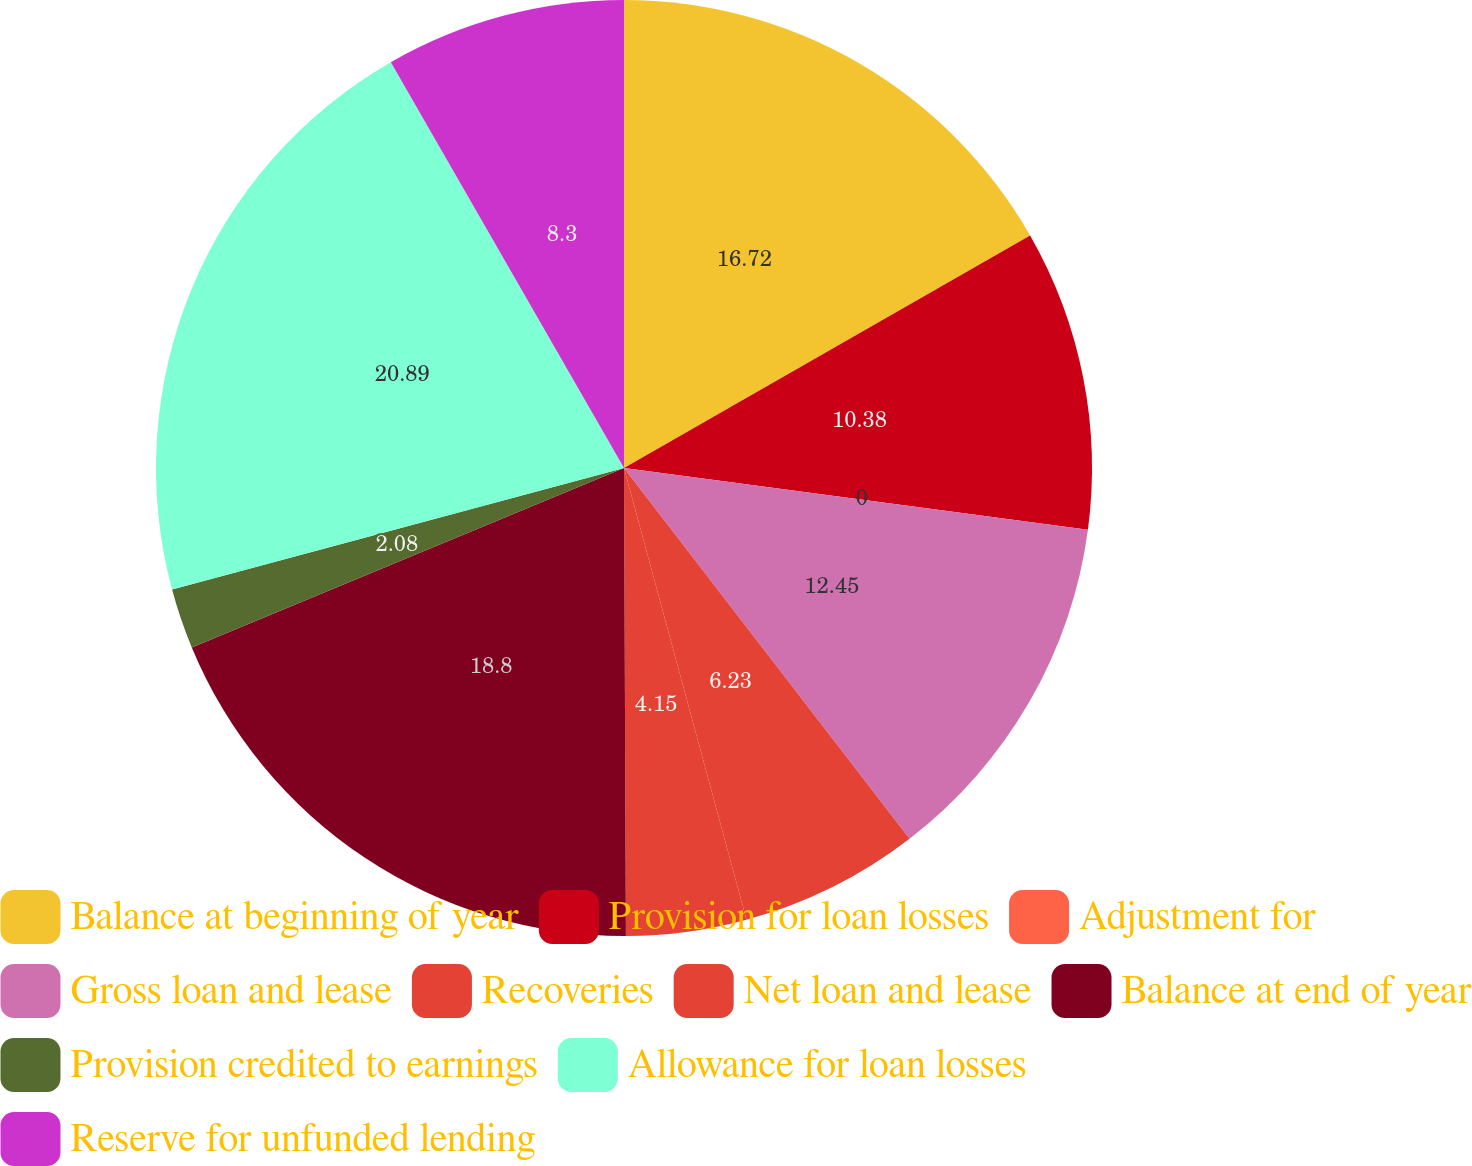<chart> <loc_0><loc_0><loc_500><loc_500><pie_chart><fcel>Balance at beginning of year<fcel>Provision for loan losses<fcel>Adjustment for<fcel>Gross loan and lease<fcel>Recoveries<fcel>Net loan and lease<fcel>Balance at end of year<fcel>Provision credited to earnings<fcel>Allowance for loan losses<fcel>Reserve for unfunded lending<nl><fcel>16.72%<fcel>10.38%<fcel>0.0%<fcel>12.45%<fcel>6.23%<fcel>4.15%<fcel>18.8%<fcel>2.08%<fcel>20.88%<fcel>8.3%<nl></chart> 